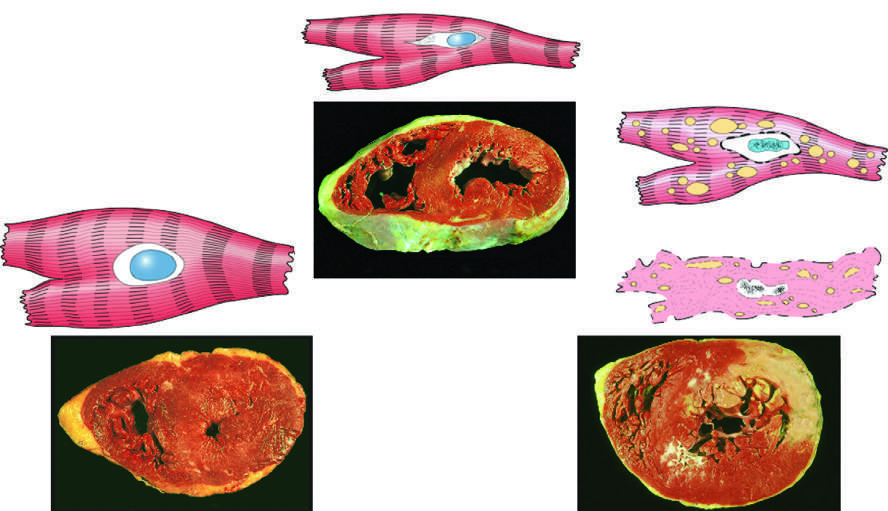what is ischemia?
Answer the question using a single word or phrase. The cause of reversible injury 